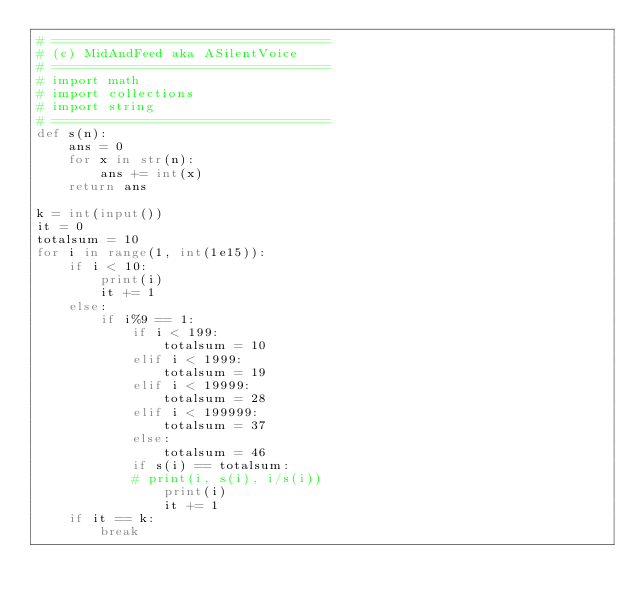<code> <loc_0><loc_0><loc_500><loc_500><_Python_># ===================================
# (c) MidAndFeed aka ASilentVoice
# ===================================
# import math 
# import collections
# import string
# ===================================
def s(n):
	ans = 0
	for x in str(n):
		ans += int(x)
	return ans

k = int(input())
it = 0
totalsum = 10
for i in range(1, int(1e15)):
	if i < 10:
		print(i)
		it += 1
	else:
		if i%9 == 1:
			if i < 199:
				totalsum = 10
			elif i < 1999:
				totalsum = 19
			elif i < 19999:
				totalsum = 28
			elif i < 199999:
				totalsum = 37
			else:
				totalsum = 46
			if s(i) == totalsum:
			# print(i, s(i), i/s(i))
				print(i)
				it += 1
	if it == k:
		break</code> 